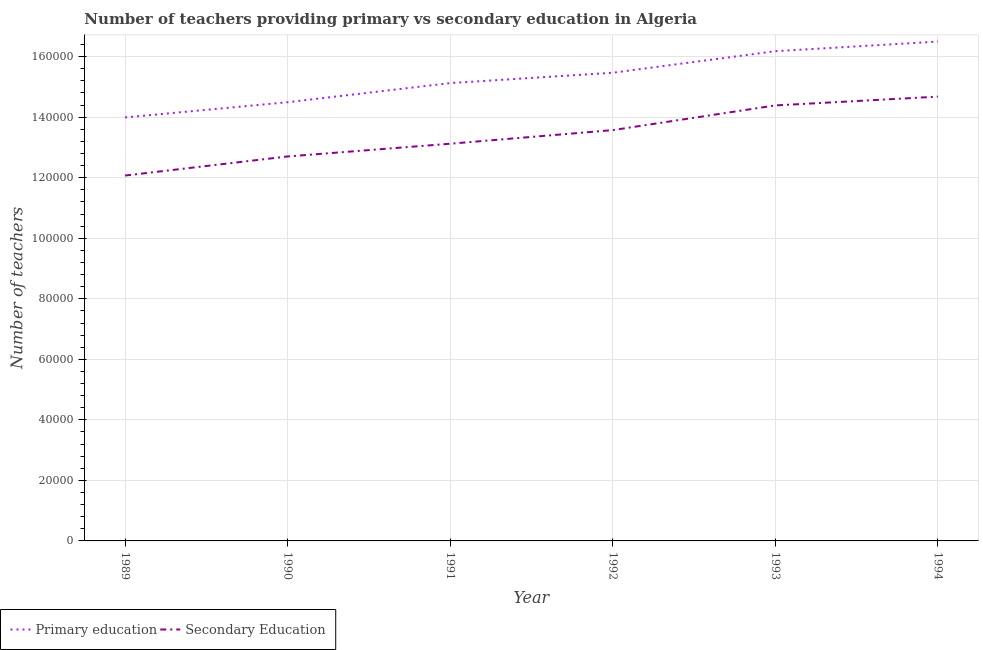How many different coloured lines are there?
Make the answer very short. 2. Does the line corresponding to number of primary teachers intersect with the line corresponding to number of secondary teachers?
Offer a terse response. No. What is the number of secondary teachers in 1991?
Provide a succinct answer. 1.31e+05. Across all years, what is the maximum number of secondary teachers?
Your answer should be very brief. 1.47e+05. Across all years, what is the minimum number of primary teachers?
Provide a succinct answer. 1.40e+05. In which year was the number of secondary teachers maximum?
Give a very brief answer. 1994. In which year was the number of primary teachers minimum?
Your answer should be very brief. 1989. What is the total number of primary teachers in the graph?
Provide a short and direct response. 9.18e+05. What is the difference between the number of primary teachers in 1992 and that in 1993?
Provide a succinct answer. -7117. What is the difference between the number of primary teachers in 1990 and the number of secondary teachers in 1993?
Your response must be concise. 1058. What is the average number of secondary teachers per year?
Your response must be concise. 1.34e+05. In the year 1992, what is the difference between the number of secondary teachers and number of primary teachers?
Ensure brevity in your answer.  -1.90e+04. In how many years, is the number of primary teachers greater than 116000?
Your answer should be very brief. 6. What is the ratio of the number of primary teachers in 1993 to that in 1994?
Ensure brevity in your answer.  0.98. What is the difference between the highest and the second highest number of secondary teachers?
Your answer should be very brief. 2905. What is the difference between the highest and the lowest number of secondary teachers?
Keep it short and to the point. 2.61e+04. In how many years, is the number of primary teachers greater than the average number of primary teachers taken over all years?
Provide a short and direct response. 3. Is the number of secondary teachers strictly greater than the number of primary teachers over the years?
Offer a terse response. No. How many lines are there?
Your answer should be compact. 2. Are the values on the major ticks of Y-axis written in scientific E-notation?
Your answer should be compact. No. How many legend labels are there?
Keep it short and to the point. 2. How are the legend labels stacked?
Make the answer very short. Horizontal. What is the title of the graph?
Give a very brief answer. Number of teachers providing primary vs secondary education in Algeria. Does "Public credit registry" appear as one of the legend labels in the graph?
Offer a terse response. No. What is the label or title of the X-axis?
Your answer should be very brief. Year. What is the label or title of the Y-axis?
Make the answer very short. Number of teachers. What is the Number of teachers of Primary education in 1989?
Your answer should be compact. 1.40e+05. What is the Number of teachers of Secondary Education in 1989?
Ensure brevity in your answer.  1.21e+05. What is the Number of teachers in Primary education in 1990?
Give a very brief answer. 1.45e+05. What is the Number of teachers of Secondary Education in 1990?
Your answer should be compact. 1.27e+05. What is the Number of teachers of Primary education in 1991?
Offer a terse response. 1.51e+05. What is the Number of teachers of Secondary Education in 1991?
Your answer should be very brief. 1.31e+05. What is the Number of teachers of Primary education in 1992?
Keep it short and to the point. 1.55e+05. What is the Number of teachers in Secondary Education in 1992?
Make the answer very short. 1.36e+05. What is the Number of teachers of Primary education in 1993?
Your answer should be very brief. 1.62e+05. What is the Number of teachers in Secondary Education in 1993?
Give a very brief answer. 1.44e+05. What is the Number of teachers of Primary education in 1994?
Make the answer very short. 1.65e+05. What is the Number of teachers of Secondary Education in 1994?
Keep it short and to the point. 1.47e+05. Across all years, what is the maximum Number of teachers in Primary education?
Your response must be concise. 1.65e+05. Across all years, what is the maximum Number of teachers in Secondary Education?
Offer a terse response. 1.47e+05. Across all years, what is the minimum Number of teachers in Primary education?
Give a very brief answer. 1.40e+05. Across all years, what is the minimum Number of teachers of Secondary Education?
Keep it short and to the point. 1.21e+05. What is the total Number of teachers in Primary education in the graph?
Make the answer very short. 9.18e+05. What is the total Number of teachers of Secondary Education in the graph?
Provide a succinct answer. 8.05e+05. What is the difference between the Number of teachers of Primary education in 1989 and that in 1990?
Give a very brief answer. -5028. What is the difference between the Number of teachers of Secondary Education in 1989 and that in 1990?
Provide a succinct answer. -6302. What is the difference between the Number of teachers of Primary education in 1989 and that in 1991?
Provide a short and direct response. -1.13e+04. What is the difference between the Number of teachers of Secondary Education in 1989 and that in 1991?
Ensure brevity in your answer.  -1.05e+04. What is the difference between the Number of teachers in Primary education in 1989 and that in 1992?
Provide a succinct answer. -1.48e+04. What is the difference between the Number of teachers in Secondary Education in 1989 and that in 1992?
Give a very brief answer. -1.50e+04. What is the difference between the Number of teachers in Primary education in 1989 and that in 1993?
Keep it short and to the point. -2.19e+04. What is the difference between the Number of teachers of Secondary Education in 1989 and that in 1993?
Keep it short and to the point. -2.32e+04. What is the difference between the Number of teachers of Primary education in 1989 and that in 1994?
Your response must be concise. -2.51e+04. What is the difference between the Number of teachers of Secondary Education in 1989 and that in 1994?
Provide a succinct answer. -2.61e+04. What is the difference between the Number of teachers of Primary education in 1990 and that in 1991?
Provide a short and direct response. -6317. What is the difference between the Number of teachers in Secondary Education in 1990 and that in 1991?
Provide a short and direct response. -4208. What is the difference between the Number of teachers of Primary education in 1990 and that in 1992?
Provide a short and direct response. -9740. What is the difference between the Number of teachers in Secondary Education in 1990 and that in 1992?
Offer a terse response. -8706. What is the difference between the Number of teachers in Primary education in 1990 and that in 1993?
Provide a succinct answer. -1.69e+04. What is the difference between the Number of teachers of Secondary Education in 1990 and that in 1993?
Provide a succinct answer. -1.69e+04. What is the difference between the Number of teachers of Primary education in 1990 and that in 1994?
Offer a terse response. -2.00e+04. What is the difference between the Number of teachers in Secondary Education in 1990 and that in 1994?
Keep it short and to the point. -1.98e+04. What is the difference between the Number of teachers in Primary education in 1991 and that in 1992?
Give a very brief answer. -3423. What is the difference between the Number of teachers in Secondary Education in 1991 and that in 1992?
Offer a very short reply. -4498. What is the difference between the Number of teachers of Primary education in 1991 and that in 1993?
Offer a very short reply. -1.05e+04. What is the difference between the Number of teachers of Secondary Education in 1991 and that in 1993?
Make the answer very short. -1.27e+04. What is the difference between the Number of teachers of Primary education in 1991 and that in 1994?
Your response must be concise. -1.37e+04. What is the difference between the Number of teachers in Secondary Education in 1991 and that in 1994?
Your answer should be compact. -1.56e+04. What is the difference between the Number of teachers in Primary education in 1992 and that in 1993?
Keep it short and to the point. -7117. What is the difference between the Number of teachers of Secondary Education in 1992 and that in 1993?
Give a very brief answer. -8157. What is the difference between the Number of teachers in Primary education in 1992 and that in 1994?
Keep it short and to the point. -1.03e+04. What is the difference between the Number of teachers in Secondary Education in 1992 and that in 1994?
Ensure brevity in your answer.  -1.11e+04. What is the difference between the Number of teachers in Primary education in 1993 and that in 1994?
Provide a succinct answer. -3180. What is the difference between the Number of teachers of Secondary Education in 1993 and that in 1994?
Ensure brevity in your answer.  -2905. What is the difference between the Number of teachers in Primary education in 1989 and the Number of teachers in Secondary Education in 1990?
Your response must be concise. 1.29e+04. What is the difference between the Number of teachers of Primary education in 1989 and the Number of teachers of Secondary Education in 1991?
Keep it short and to the point. 8685. What is the difference between the Number of teachers of Primary education in 1989 and the Number of teachers of Secondary Education in 1992?
Provide a short and direct response. 4187. What is the difference between the Number of teachers of Primary education in 1989 and the Number of teachers of Secondary Education in 1993?
Make the answer very short. -3970. What is the difference between the Number of teachers in Primary education in 1989 and the Number of teachers in Secondary Education in 1994?
Ensure brevity in your answer.  -6875. What is the difference between the Number of teachers of Primary education in 1990 and the Number of teachers of Secondary Education in 1991?
Your answer should be very brief. 1.37e+04. What is the difference between the Number of teachers of Primary education in 1990 and the Number of teachers of Secondary Education in 1992?
Provide a succinct answer. 9215. What is the difference between the Number of teachers in Primary education in 1990 and the Number of teachers in Secondary Education in 1993?
Your answer should be very brief. 1058. What is the difference between the Number of teachers in Primary education in 1990 and the Number of teachers in Secondary Education in 1994?
Provide a succinct answer. -1847. What is the difference between the Number of teachers of Primary education in 1991 and the Number of teachers of Secondary Education in 1992?
Make the answer very short. 1.55e+04. What is the difference between the Number of teachers of Primary education in 1991 and the Number of teachers of Secondary Education in 1993?
Your answer should be very brief. 7375. What is the difference between the Number of teachers in Primary education in 1991 and the Number of teachers in Secondary Education in 1994?
Provide a short and direct response. 4470. What is the difference between the Number of teachers of Primary education in 1992 and the Number of teachers of Secondary Education in 1993?
Keep it short and to the point. 1.08e+04. What is the difference between the Number of teachers in Primary education in 1992 and the Number of teachers in Secondary Education in 1994?
Keep it short and to the point. 7893. What is the difference between the Number of teachers in Primary education in 1993 and the Number of teachers in Secondary Education in 1994?
Provide a short and direct response. 1.50e+04. What is the average Number of teachers in Primary education per year?
Provide a short and direct response. 1.53e+05. What is the average Number of teachers in Secondary Education per year?
Offer a very short reply. 1.34e+05. In the year 1989, what is the difference between the Number of teachers of Primary education and Number of teachers of Secondary Education?
Give a very brief answer. 1.92e+04. In the year 1990, what is the difference between the Number of teachers in Primary education and Number of teachers in Secondary Education?
Offer a very short reply. 1.79e+04. In the year 1991, what is the difference between the Number of teachers of Primary education and Number of teachers of Secondary Education?
Offer a very short reply. 2.00e+04. In the year 1992, what is the difference between the Number of teachers of Primary education and Number of teachers of Secondary Education?
Offer a terse response. 1.90e+04. In the year 1993, what is the difference between the Number of teachers of Primary education and Number of teachers of Secondary Education?
Offer a very short reply. 1.79e+04. In the year 1994, what is the difference between the Number of teachers of Primary education and Number of teachers of Secondary Education?
Offer a terse response. 1.82e+04. What is the ratio of the Number of teachers in Primary education in 1989 to that in 1990?
Provide a short and direct response. 0.97. What is the ratio of the Number of teachers in Secondary Education in 1989 to that in 1990?
Offer a very short reply. 0.95. What is the ratio of the Number of teachers in Primary education in 1989 to that in 1991?
Your answer should be very brief. 0.93. What is the ratio of the Number of teachers in Secondary Education in 1989 to that in 1991?
Provide a short and direct response. 0.92. What is the ratio of the Number of teachers in Primary education in 1989 to that in 1992?
Your response must be concise. 0.9. What is the ratio of the Number of teachers of Secondary Education in 1989 to that in 1992?
Offer a terse response. 0.89. What is the ratio of the Number of teachers in Primary education in 1989 to that in 1993?
Make the answer very short. 0.86. What is the ratio of the Number of teachers of Secondary Education in 1989 to that in 1993?
Offer a terse response. 0.84. What is the ratio of the Number of teachers in Primary education in 1989 to that in 1994?
Provide a succinct answer. 0.85. What is the ratio of the Number of teachers in Secondary Education in 1989 to that in 1994?
Give a very brief answer. 0.82. What is the ratio of the Number of teachers of Primary education in 1990 to that in 1991?
Keep it short and to the point. 0.96. What is the ratio of the Number of teachers in Secondary Education in 1990 to that in 1991?
Make the answer very short. 0.97. What is the ratio of the Number of teachers of Primary education in 1990 to that in 1992?
Provide a succinct answer. 0.94. What is the ratio of the Number of teachers of Secondary Education in 1990 to that in 1992?
Give a very brief answer. 0.94. What is the ratio of the Number of teachers of Primary education in 1990 to that in 1993?
Your answer should be very brief. 0.9. What is the ratio of the Number of teachers in Secondary Education in 1990 to that in 1993?
Provide a short and direct response. 0.88. What is the ratio of the Number of teachers of Primary education in 1990 to that in 1994?
Offer a terse response. 0.88. What is the ratio of the Number of teachers in Secondary Education in 1990 to that in 1994?
Offer a very short reply. 0.87. What is the ratio of the Number of teachers in Primary education in 1991 to that in 1992?
Your answer should be compact. 0.98. What is the ratio of the Number of teachers of Secondary Education in 1991 to that in 1992?
Provide a succinct answer. 0.97. What is the ratio of the Number of teachers in Primary education in 1991 to that in 1993?
Keep it short and to the point. 0.93. What is the ratio of the Number of teachers of Secondary Education in 1991 to that in 1993?
Give a very brief answer. 0.91. What is the ratio of the Number of teachers in Primary education in 1991 to that in 1994?
Ensure brevity in your answer.  0.92. What is the ratio of the Number of teachers in Secondary Education in 1991 to that in 1994?
Offer a terse response. 0.89. What is the ratio of the Number of teachers in Primary education in 1992 to that in 1993?
Provide a succinct answer. 0.96. What is the ratio of the Number of teachers in Secondary Education in 1992 to that in 1993?
Your answer should be compact. 0.94. What is the ratio of the Number of teachers of Primary education in 1992 to that in 1994?
Offer a very short reply. 0.94. What is the ratio of the Number of teachers of Secondary Education in 1992 to that in 1994?
Offer a terse response. 0.92. What is the ratio of the Number of teachers in Primary education in 1993 to that in 1994?
Ensure brevity in your answer.  0.98. What is the ratio of the Number of teachers in Secondary Education in 1993 to that in 1994?
Offer a very short reply. 0.98. What is the difference between the highest and the second highest Number of teachers in Primary education?
Provide a short and direct response. 3180. What is the difference between the highest and the second highest Number of teachers of Secondary Education?
Ensure brevity in your answer.  2905. What is the difference between the highest and the lowest Number of teachers in Primary education?
Provide a succinct answer. 2.51e+04. What is the difference between the highest and the lowest Number of teachers of Secondary Education?
Ensure brevity in your answer.  2.61e+04. 